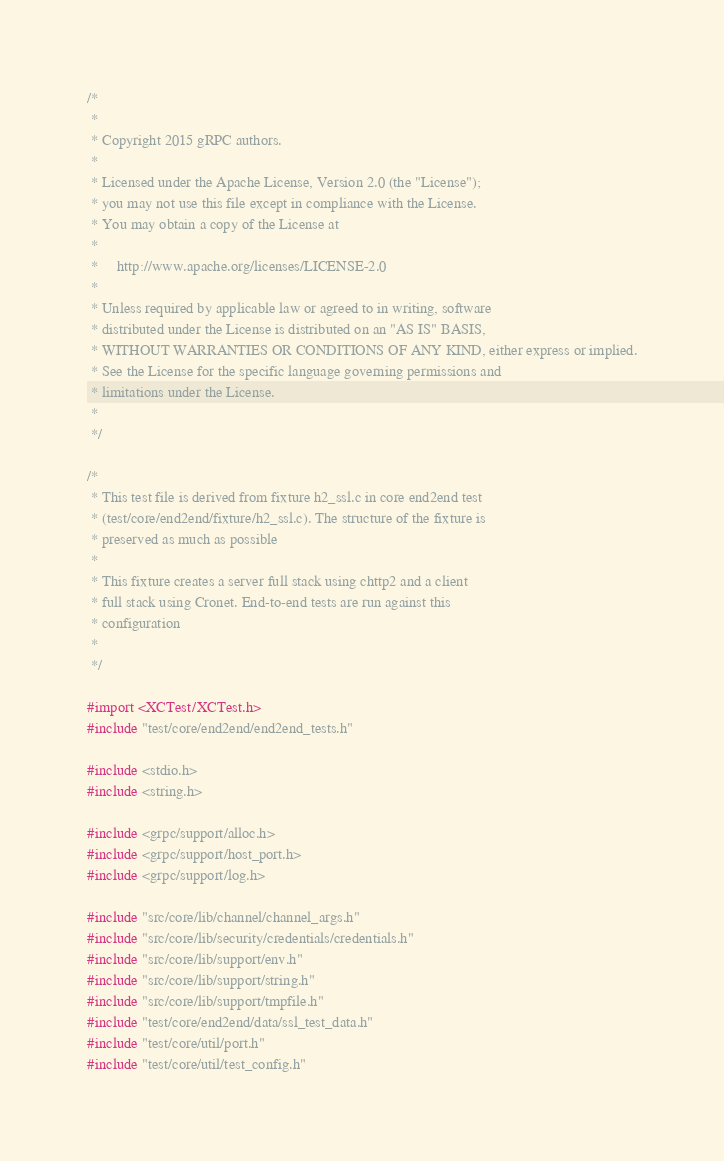Convert code to text. <code><loc_0><loc_0><loc_500><loc_500><_ObjectiveC_>/*
 *
 * Copyright 2015 gRPC authors.
 *
 * Licensed under the Apache License, Version 2.0 (the "License");
 * you may not use this file except in compliance with the License.
 * You may obtain a copy of the License at
 *
 *     http://www.apache.org/licenses/LICENSE-2.0
 *
 * Unless required by applicable law or agreed to in writing, software
 * distributed under the License is distributed on an "AS IS" BASIS,
 * WITHOUT WARRANTIES OR CONDITIONS OF ANY KIND, either express or implied.
 * See the License for the specific language governing permissions and
 * limitations under the License.
 *
 */

/*
 * This test file is derived from fixture h2_ssl.c in core end2end test
 * (test/core/end2end/fixture/h2_ssl.c). The structure of the fixture is
 * preserved as much as possible
 *
 * This fixture creates a server full stack using chttp2 and a client
 * full stack using Cronet. End-to-end tests are run against this
 * configuration
 *
 */

#import <XCTest/XCTest.h>
#include "test/core/end2end/end2end_tests.h"

#include <stdio.h>
#include <string.h>

#include <grpc/support/alloc.h>
#include <grpc/support/host_port.h>
#include <grpc/support/log.h>

#include "src/core/lib/channel/channel_args.h"
#include "src/core/lib/security/credentials/credentials.h"
#include "src/core/lib/support/env.h"
#include "src/core/lib/support/string.h"
#include "src/core/lib/support/tmpfile.h"
#include "test/core/end2end/data/ssl_test_data.h"
#include "test/core/util/port.h"
#include "test/core/util/test_config.h"
</code> 